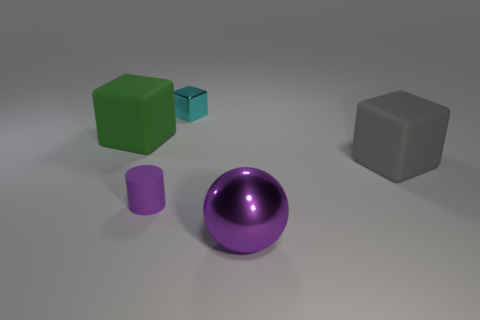What number of rubber objects are both right of the cyan metal cube and left of the rubber cylinder?
Your response must be concise. 0. What color is the big rubber block to the right of the small cyan shiny cube that is to the left of the shiny sphere?
Give a very brief answer. Gray. Are there an equal number of big blocks in front of the large green rubber thing and tiny blue blocks?
Your answer should be compact. No. There is a large cube to the right of the tiny thing behind the big gray cube; what number of tiny cyan objects are in front of it?
Your answer should be compact. 0. What is the color of the rubber cube to the right of the big purple thing?
Your response must be concise. Gray. There is a big object that is both to the left of the gray matte thing and in front of the green cube; what is its material?
Make the answer very short. Metal. There is a block that is in front of the big green matte object; what number of tiny cubes are left of it?
Your answer should be very brief. 1. What is the shape of the large green rubber object?
Give a very brief answer. Cube. There is a small thing that is made of the same material as the large gray thing; what shape is it?
Offer a terse response. Cylinder. There is a purple thing that is behind the large purple thing; is its shape the same as the big green rubber thing?
Your response must be concise. No. 